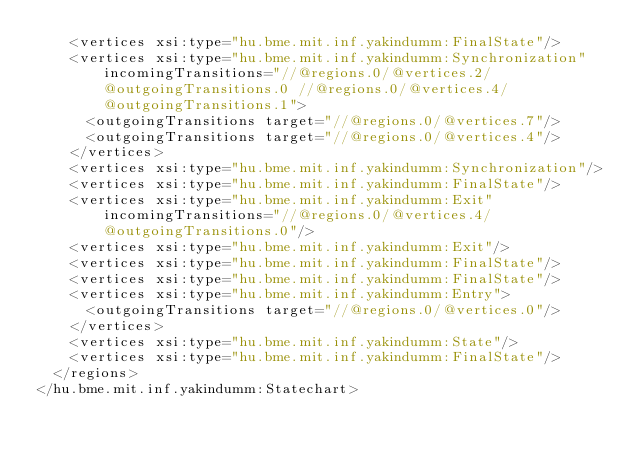<code> <loc_0><loc_0><loc_500><loc_500><_XML_>    <vertices xsi:type="hu.bme.mit.inf.yakindumm:FinalState"/>
    <vertices xsi:type="hu.bme.mit.inf.yakindumm:Synchronization" incomingTransitions="//@regions.0/@vertices.2/@outgoingTransitions.0 //@regions.0/@vertices.4/@outgoingTransitions.1">
      <outgoingTransitions target="//@regions.0/@vertices.7"/>
      <outgoingTransitions target="//@regions.0/@vertices.4"/>
    </vertices>
    <vertices xsi:type="hu.bme.mit.inf.yakindumm:Synchronization"/>
    <vertices xsi:type="hu.bme.mit.inf.yakindumm:FinalState"/>
    <vertices xsi:type="hu.bme.mit.inf.yakindumm:Exit" incomingTransitions="//@regions.0/@vertices.4/@outgoingTransitions.0"/>
    <vertices xsi:type="hu.bme.mit.inf.yakindumm:Exit"/>
    <vertices xsi:type="hu.bme.mit.inf.yakindumm:FinalState"/>
    <vertices xsi:type="hu.bme.mit.inf.yakindumm:FinalState"/>
    <vertices xsi:type="hu.bme.mit.inf.yakindumm:Entry">
      <outgoingTransitions target="//@regions.0/@vertices.0"/>
    </vertices>
    <vertices xsi:type="hu.bme.mit.inf.yakindumm:State"/>
    <vertices xsi:type="hu.bme.mit.inf.yakindumm:FinalState"/>
  </regions>
</hu.bme.mit.inf.yakindumm:Statechart>
</code> 